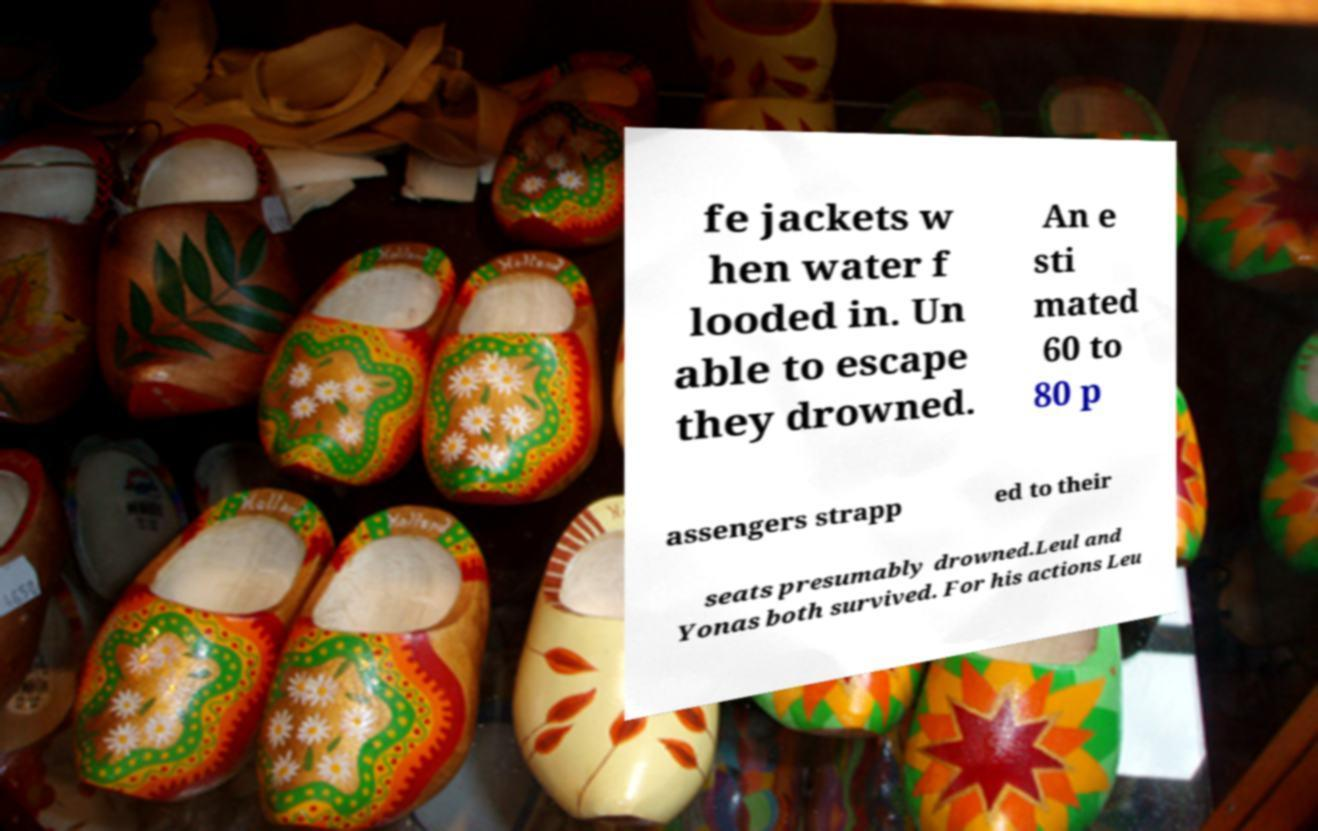What messages or text are displayed in this image? I need them in a readable, typed format. fe jackets w hen water f looded in. Un able to escape they drowned. An e sti mated 60 to 80 p assengers strapp ed to their seats presumably drowned.Leul and Yonas both survived. For his actions Leu 